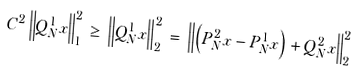Convert formula to latex. <formula><loc_0><loc_0><loc_500><loc_500>C ^ { 2 } \left \| Q _ { N } ^ { 1 } x \right \| _ { 1 } ^ { 2 } \, \geq \, \left \| Q _ { N } ^ { 1 } x \right \| _ { 2 } ^ { 2 } \, = \, \left \| \left ( P _ { N } ^ { 2 } x - P _ { N } ^ { 1 } x \right ) + Q _ { N } ^ { 2 } x \right \| _ { 2 } ^ { 2 }</formula> 